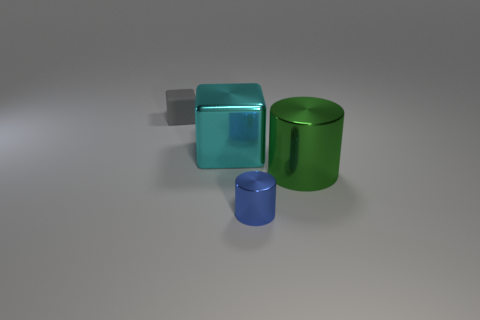There is a tiny metal object; what shape is it? cylinder 